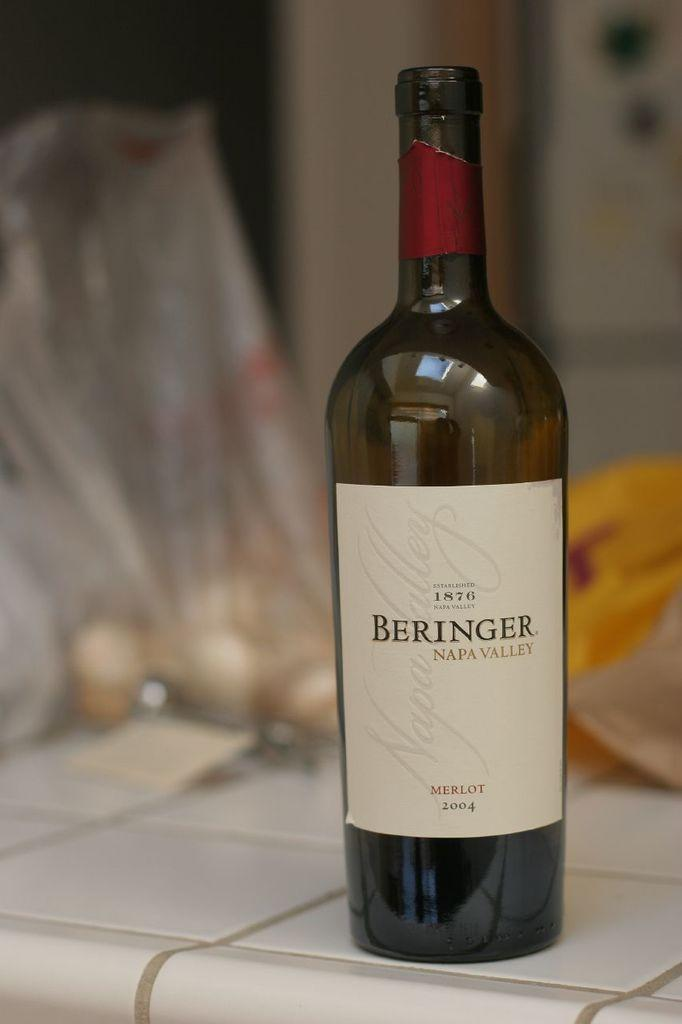<image>
Relay a brief, clear account of the picture shown. bottle of merlot beringer wine on a white tile counter top 